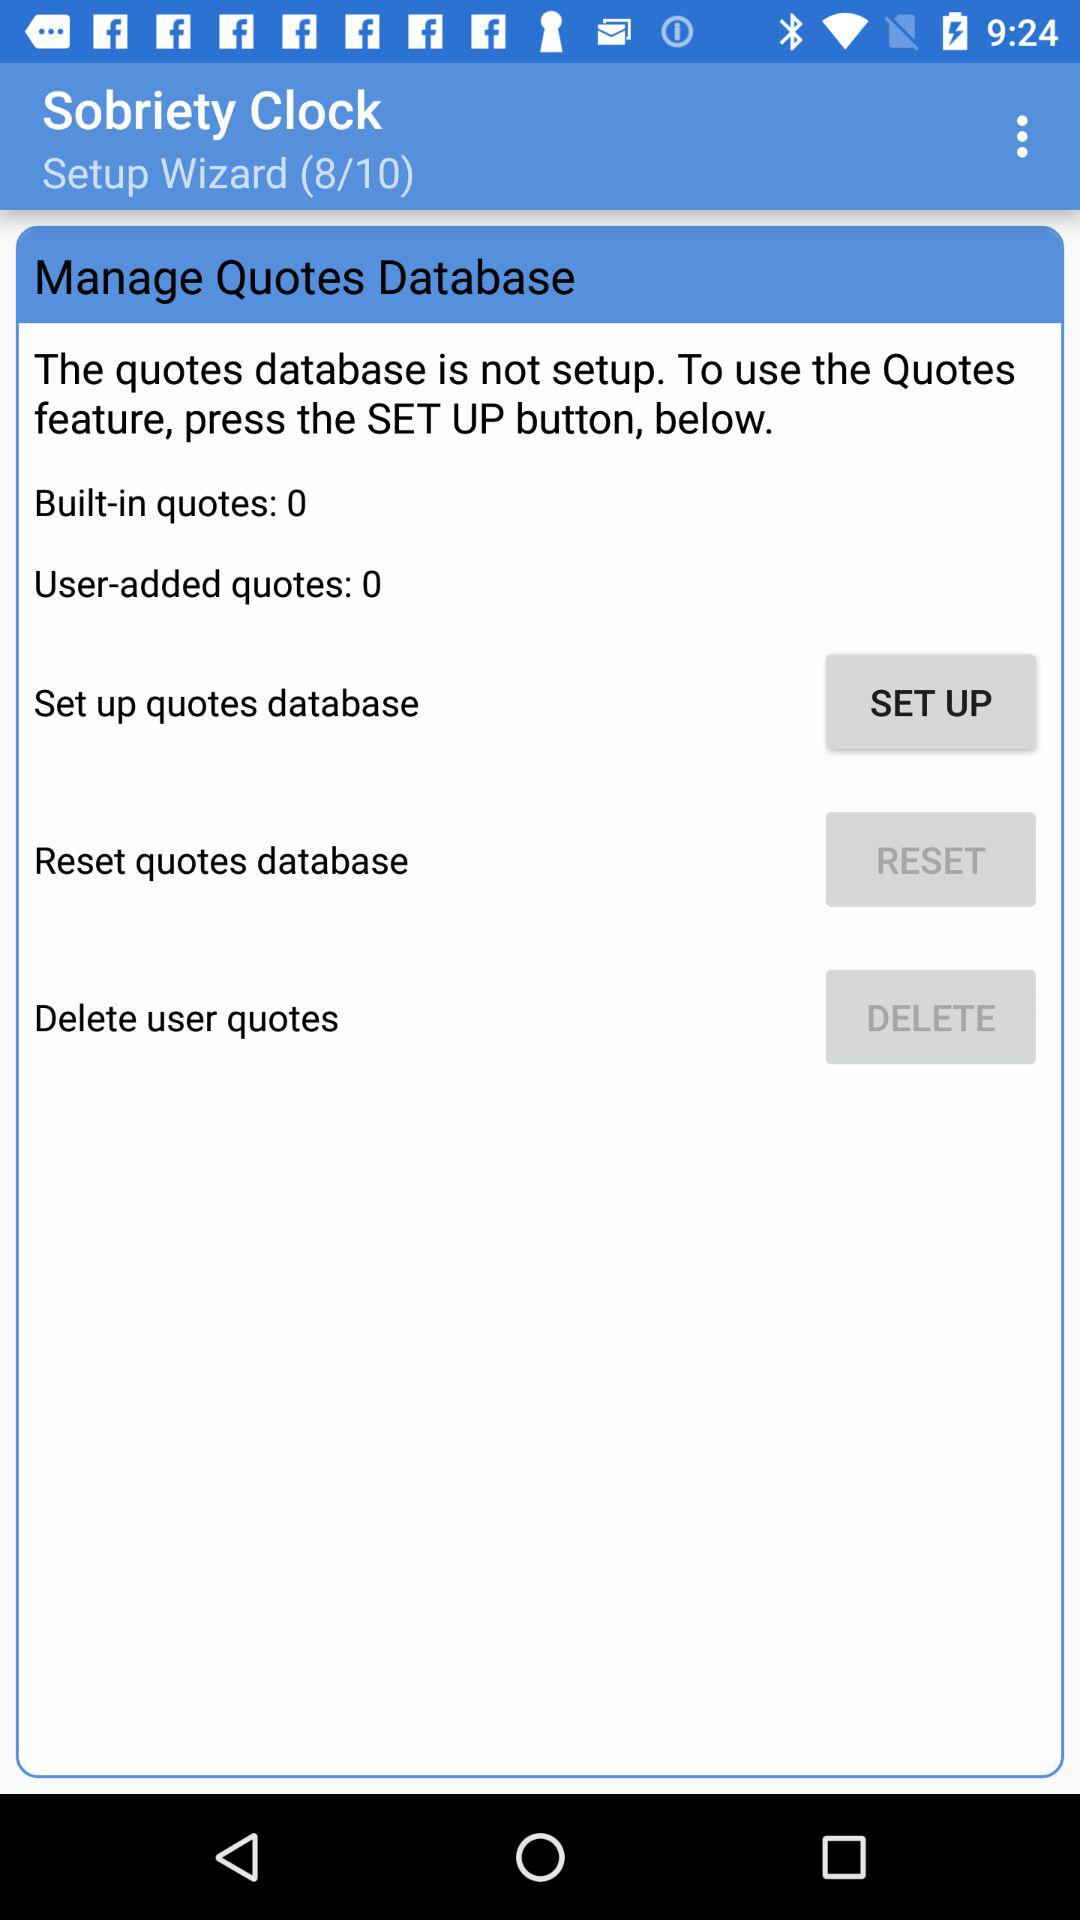What is the status of set up quotes database?
When the provided information is insufficient, respond with <no answer>. <no answer> 